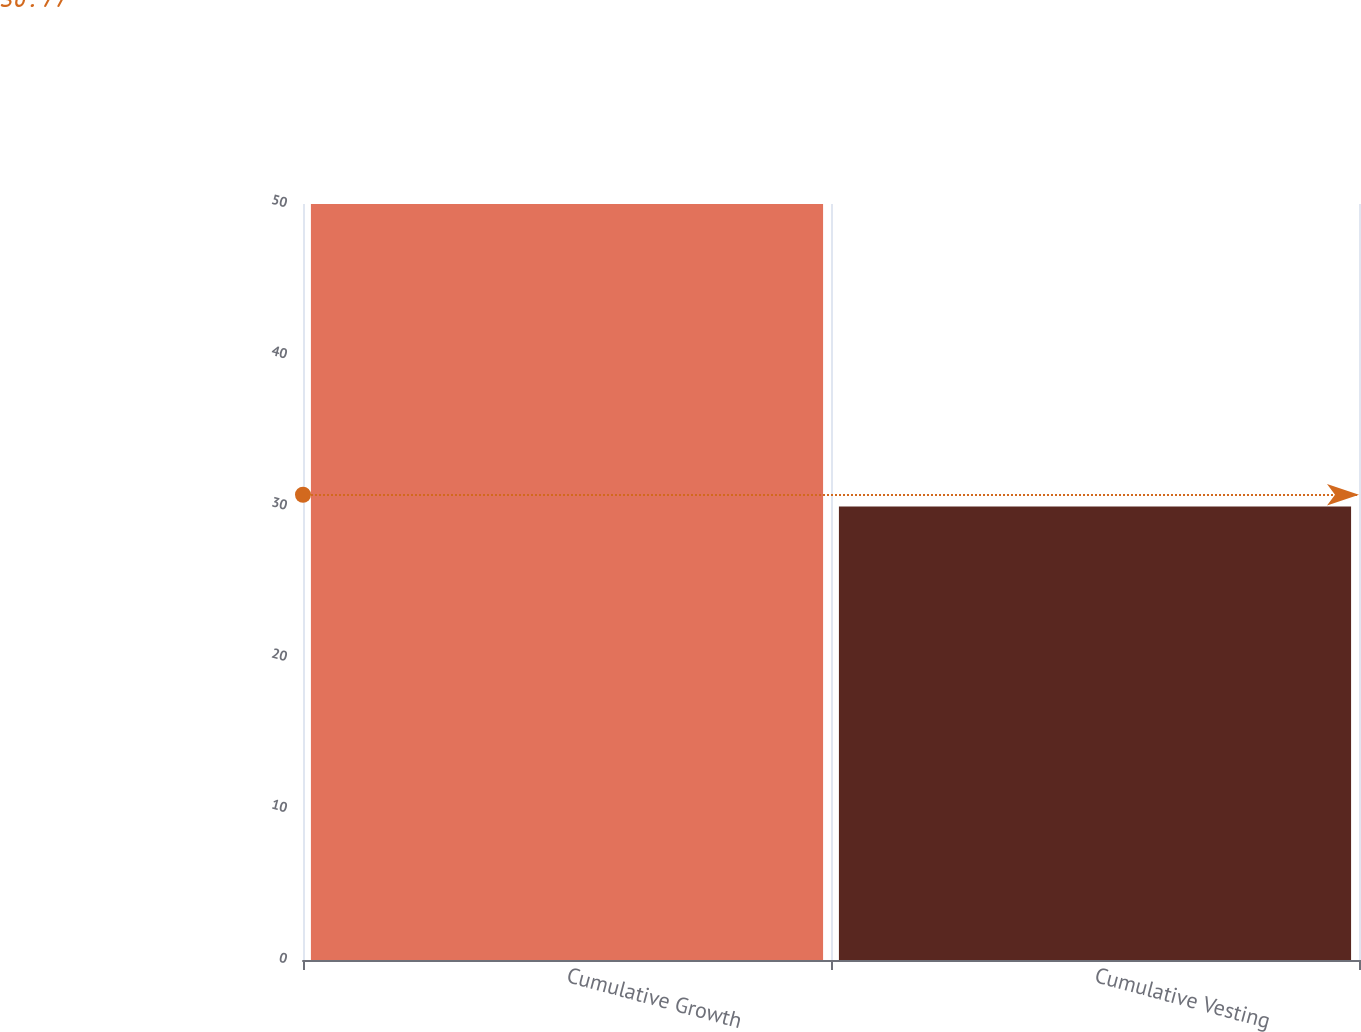<chart> <loc_0><loc_0><loc_500><loc_500><bar_chart><fcel>Cumulative Growth<fcel>Cumulative Vesting<nl><fcel>50<fcel>30<nl></chart> 